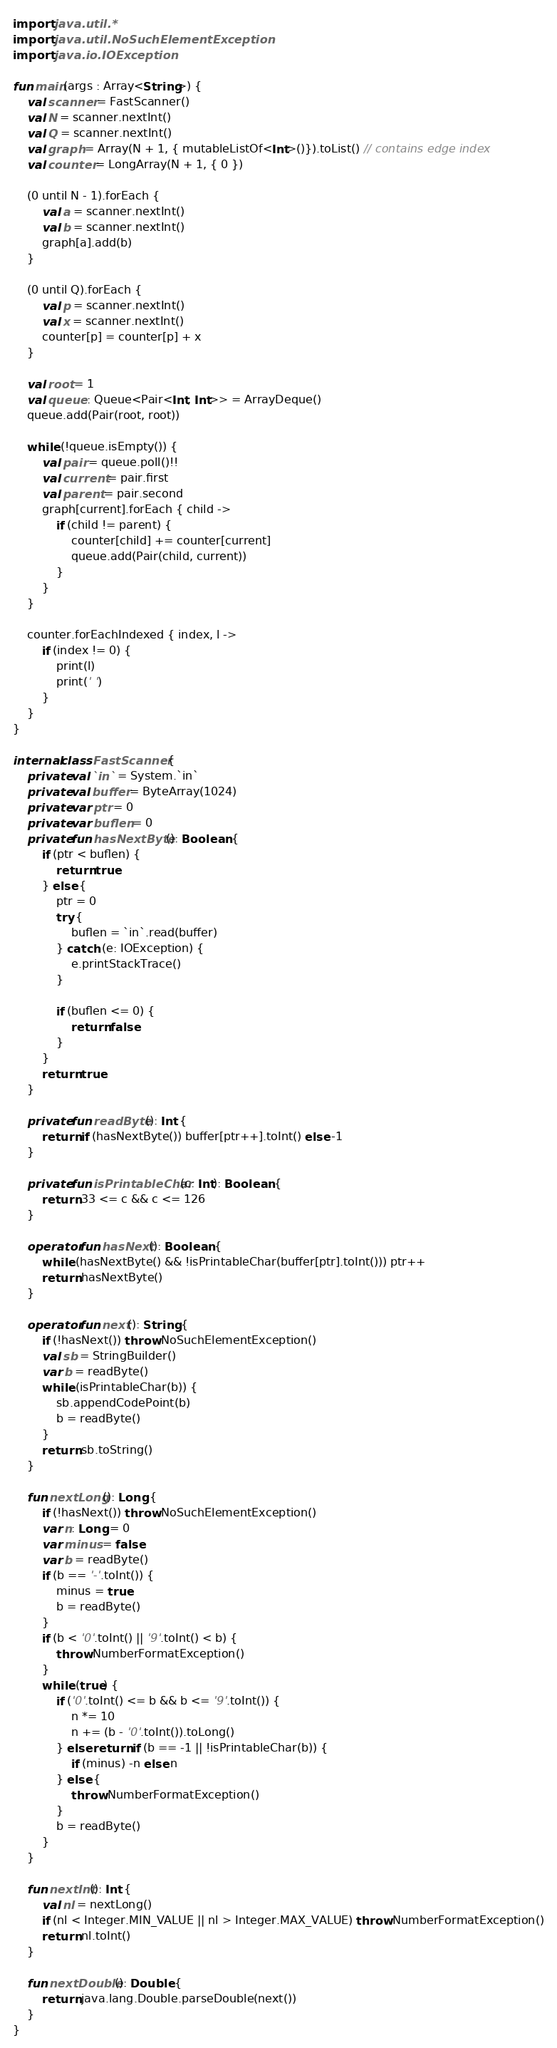<code> <loc_0><loc_0><loc_500><loc_500><_Kotlin_>import java.util.*
import java.util.NoSuchElementException
import java.io.IOException

fun main(args : Array<String>) {
    val scanner = FastScanner()
    val N = scanner.nextInt()
    val Q = scanner.nextInt()
    val graph = Array(N + 1, { mutableListOf<Int>()}).toList() // contains edge index
    val counter = LongArray(N + 1, { 0 })

    (0 until N - 1).forEach {
        val a = scanner.nextInt()
        val b = scanner.nextInt()
        graph[a].add(b)
    }

    (0 until Q).forEach {
        val p = scanner.nextInt()
        val x = scanner.nextInt()
        counter[p] = counter[p] + x
    }

    val root = 1
    val queue : Queue<Pair<Int, Int>> = ArrayDeque()
    queue.add(Pair(root, root))

    while (!queue.isEmpty()) {
        val pair = queue.poll()!!
        val current = pair.first
        val parent = pair.second
        graph[current].forEach { child ->
            if (child != parent) {
                counter[child] += counter[current]
                queue.add(Pair(child, current))
            }
        }
    }

    counter.forEachIndexed { index, l ->
        if (index != 0) {
            print(l)
            print(' ')
        }
    }
}

internal class FastScanner {
    private val `in` = System.`in`
    private val buffer = ByteArray(1024)
    private var ptr = 0
    private var buflen = 0
    private fun hasNextByte(): Boolean {
        if (ptr < buflen) {
            return true
        } else {
            ptr = 0
            try {
                buflen = `in`.read(buffer)
            } catch (e: IOException) {
                e.printStackTrace()
            }

            if (buflen <= 0) {
                return false
            }
        }
        return true
    }

    private fun readByte(): Int {
        return if (hasNextByte()) buffer[ptr++].toInt() else -1
    }

    private fun isPrintableChar(c: Int): Boolean {
        return 33 <= c && c <= 126
    }

    operator fun hasNext(): Boolean {
        while (hasNextByte() && !isPrintableChar(buffer[ptr].toInt())) ptr++
        return hasNextByte()
    }

    operator fun next(): String {
        if (!hasNext()) throw NoSuchElementException()
        val sb = StringBuilder()
        var b = readByte()
        while (isPrintableChar(b)) {
            sb.appendCodePoint(b)
            b = readByte()
        }
        return sb.toString()
    }

    fun nextLong(): Long {
        if (!hasNext()) throw NoSuchElementException()
        var n: Long = 0
        var minus = false
        var b = readByte()
        if (b == '-'.toInt()) {
            minus = true
            b = readByte()
        }
        if (b < '0'.toInt() || '9'.toInt() < b) {
            throw NumberFormatException()
        }
        while (true) {
            if ('0'.toInt() <= b && b <= '9'.toInt()) {
                n *= 10
                n += (b - '0'.toInt()).toLong()
            } else return if (b == -1 || !isPrintableChar(b)) {
                if (minus) -n else n
            } else {
                throw NumberFormatException()
            }
            b = readByte()
        }
    }

    fun nextInt(): Int {
        val nl = nextLong()
        if (nl < Integer.MIN_VALUE || nl > Integer.MAX_VALUE) throw NumberFormatException()
        return nl.toInt()
    }

    fun nextDouble(): Double {
        return java.lang.Double.parseDouble(next())
    }
}</code> 